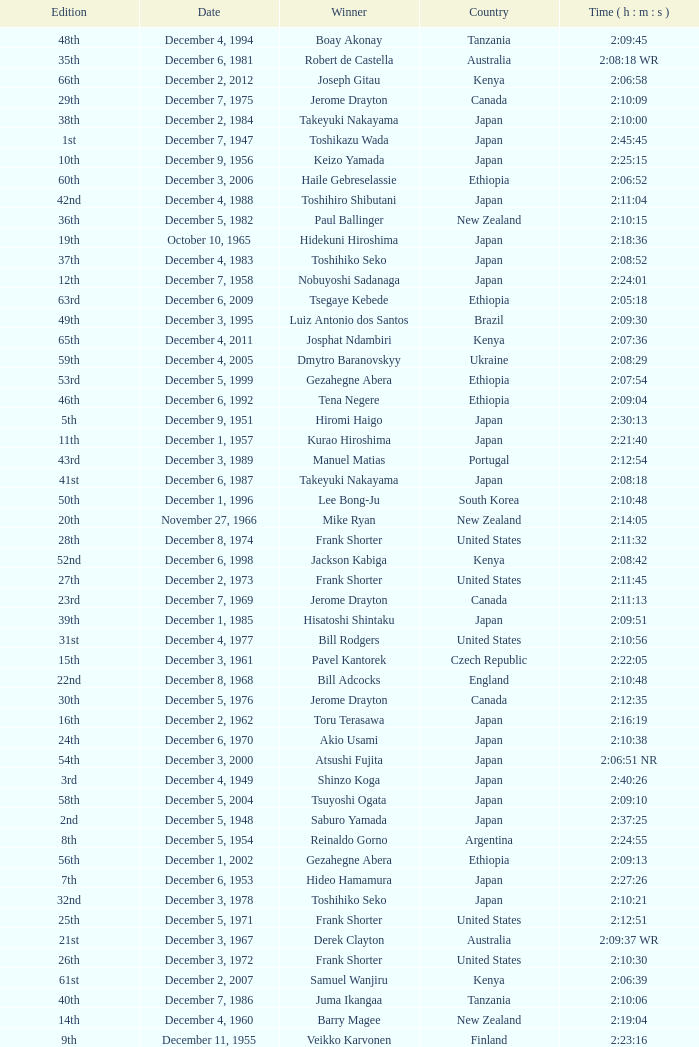What was the nationality of the winner of the 42nd Edition? Japan. Give me the full table as a dictionary. {'header': ['Edition', 'Date', 'Winner', 'Country', 'Time ( h : m : s )'], 'rows': [['48th', 'December 4, 1994', 'Boay Akonay', 'Tanzania', '2:09:45'], ['35th', 'December 6, 1981', 'Robert de Castella', 'Australia', '2:08:18 WR'], ['66th', 'December 2, 2012', 'Joseph Gitau', 'Kenya', '2:06:58'], ['29th', 'December 7, 1975', 'Jerome Drayton', 'Canada', '2:10:09'], ['38th', 'December 2, 1984', 'Takeyuki Nakayama', 'Japan', '2:10:00'], ['1st', 'December 7, 1947', 'Toshikazu Wada', 'Japan', '2:45:45'], ['10th', 'December 9, 1956', 'Keizo Yamada', 'Japan', '2:25:15'], ['60th', 'December 3, 2006', 'Haile Gebreselassie', 'Ethiopia', '2:06:52'], ['42nd', 'December 4, 1988', 'Toshihiro Shibutani', 'Japan', '2:11:04'], ['36th', 'December 5, 1982', 'Paul Ballinger', 'New Zealand', '2:10:15'], ['19th', 'October 10, 1965', 'Hidekuni Hiroshima', 'Japan', '2:18:36'], ['37th', 'December 4, 1983', 'Toshihiko Seko', 'Japan', '2:08:52'], ['12th', 'December 7, 1958', 'Nobuyoshi Sadanaga', 'Japan', '2:24:01'], ['63rd', 'December 6, 2009', 'Tsegaye Kebede', 'Ethiopia', '2:05:18'], ['49th', 'December 3, 1995', 'Luiz Antonio dos Santos', 'Brazil', '2:09:30'], ['65th', 'December 4, 2011', 'Josphat Ndambiri', 'Kenya', '2:07:36'], ['59th', 'December 4, 2005', 'Dmytro Baranovskyy', 'Ukraine', '2:08:29'], ['53rd', 'December 5, 1999', 'Gezahegne Abera', 'Ethiopia', '2:07:54'], ['46th', 'December 6, 1992', 'Tena Negere', 'Ethiopia', '2:09:04'], ['5th', 'December 9, 1951', 'Hiromi Haigo', 'Japan', '2:30:13'], ['11th', 'December 1, 1957', 'Kurao Hiroshima', 'Japan', '2:21:40'], ['43rd', 'December 3, 1989', 'Manuel Matias', 'Portugal', '2:12:54'], ['41st', 'December 6, 1987', 'Takeyuki Nakayama', 'Japan', '2:08:18'], ['50th', 'December 1, 1996', 'Lee Bong-Ju', 'South Korea', '2:10:48'], ['20th', 'November 27, 1966', 'Mike Ryan', 'New Zealand', '2:14:05'], ['28th', 'December 8, 1974', 'Frank Shorter', 'United States', '2:11:32'], ['52nd', 'December 6, 1998', 'Jackson Kabiga', 'Kenya', '2:08:42'], ['27th', 'December 2, 1973', 'Frank Shorter', 'United States', '2:11:45'], ['23rd', 'December 7, 1969', 'Jerome Drayton', 'Canada', '2:11:13'], ['39th', 'December 1, 1985', 'Hisatoshi Shintaku', 'Japan', '2:09:51'], ['31st', 'December 4, 1977', 'Bill Rodgers', 'United States', '2:10:56'], ['15th', 'December 3, 1961', 'Pavel Kantorek', 'Czech Republic', '2:22:05'], ['22nd', 'December 8, 1968', 'Bill Adcocks', 'England', '2:10:48'], ['30th', 'December 5, 1976', 'Jerome Drayton', 'Canada', '2:12:35'], ['16th', 'December 2, 1962', 'Toru Terasawa', 'Japan', '2:16:19'], ['24th', 'December 6, 1970', 'Akio Usami', 'Japan', '2:10:38'], ['54th', 'December 3, 2000', 'Atsushi Fujita', 'Japan', '2:06:51 NR'], ['3rd', 'December 4, 1949', 'Shinzo Koga', 'Japan', '2:40:26'], ['58th', 'December 5, 2004', 'Tsuyoshi Ogata', 'Japan', '2:09:10'], ['2nd', 'December 5, 1948', 'Saburo Yamada', 'Japan', '2:37:25'], ['8th', 'December 5, 1954', 'Reinaldo Gorno', 'Argentina', '2:24:55'], ['56th', 'December 1, 2002', 'Gezahegne Abera', 'Ethiopia', '2:09:13'], ['7th', 'December 6, 1953', 'Hideo Hamamura', 'Japan', '2:27:26'], ['32nd', 'December 3, 1978', 'Toshihiko Seko', 'Japan', '2:10:21'], ['25th', 'December 5, 1971', 'Frank Shorter', 'United States', '2:12:51'], ['21st', 'December 3, 1967', 'Derek Clayton', 'Australia', '2:09:37 WR'], ['26th', 'December 3, 1972', 'Frank Shorter', 'United States', '2:10:30'], ['61st', 'December 2, 2007', 'Samuel Wanjiru', 'Kenya', '2:06:39'], ['40th', 'December 7, 1986', 'Juma Ikangaa', 'Tanzania', '2:10:06'], ['14th', 'December 4, 1960', 'Barry Magee', 'New Zealand', '2:19:04'], ['9th', 'December 11, 1955', 'Veikko Karvonen', 'Finland', '2:23:16'], ['44th', 'December 2, 1990', 'Belayneh Densamo', 'Ethiopia', '2:11:35'], ['34th', 'December 7, 1980', 'Toshihiko Seko', 'Japan', '2:09:45'], ['55th', 'December 2, 2001', 'Gezahegne Abera', 'Ethiopia', '2:09:25'], ['51st', 'December 7, 1997', 'Josia Thugwane', 'South Africa', '2:07:28'], ['33rd', 'December 2, 1979', 'Toshihiko Seko', 'Japan', '2:10:35'], ['4th', 'December 10, 1950', 'Shunji Koyanagi', 'Japan', '2:30:47'], ['57th', 'December 7, 2003', 'Tomoaki Kunichika', 'Japan', '2:07:52'], ['17th', 'October 15, 1963', 'Jeff Julian', 'New Zealand', '2:18:01'], ['6th', 'December 7, 1952', 'Katsuo Nishida', 'Japan', '2:27:59'], ['47th', 'December 5, 1993', 'Dionicio Cerón', 'Mexico', '2:08:51'], ['18th', 'December 6, 1964', 'Toru Terasawa', 'Japan', '2:14:49'], ['62nd', 'December 7, 2008', 'Tsegaye Kebede', 'Ethiopia', '2:06:10'], ['64th', 'December 5, 2010', 'Jaouad Gharib', 'Morocco', '2:08:24'], ['13th', 'November 8, 1959', 'Kurao Hiroshima', 'Japan', '2:29:34'], ['45th', 'December 1, 1991', 'Shuichi Morita', 'Japan', '2:10:58']]} 